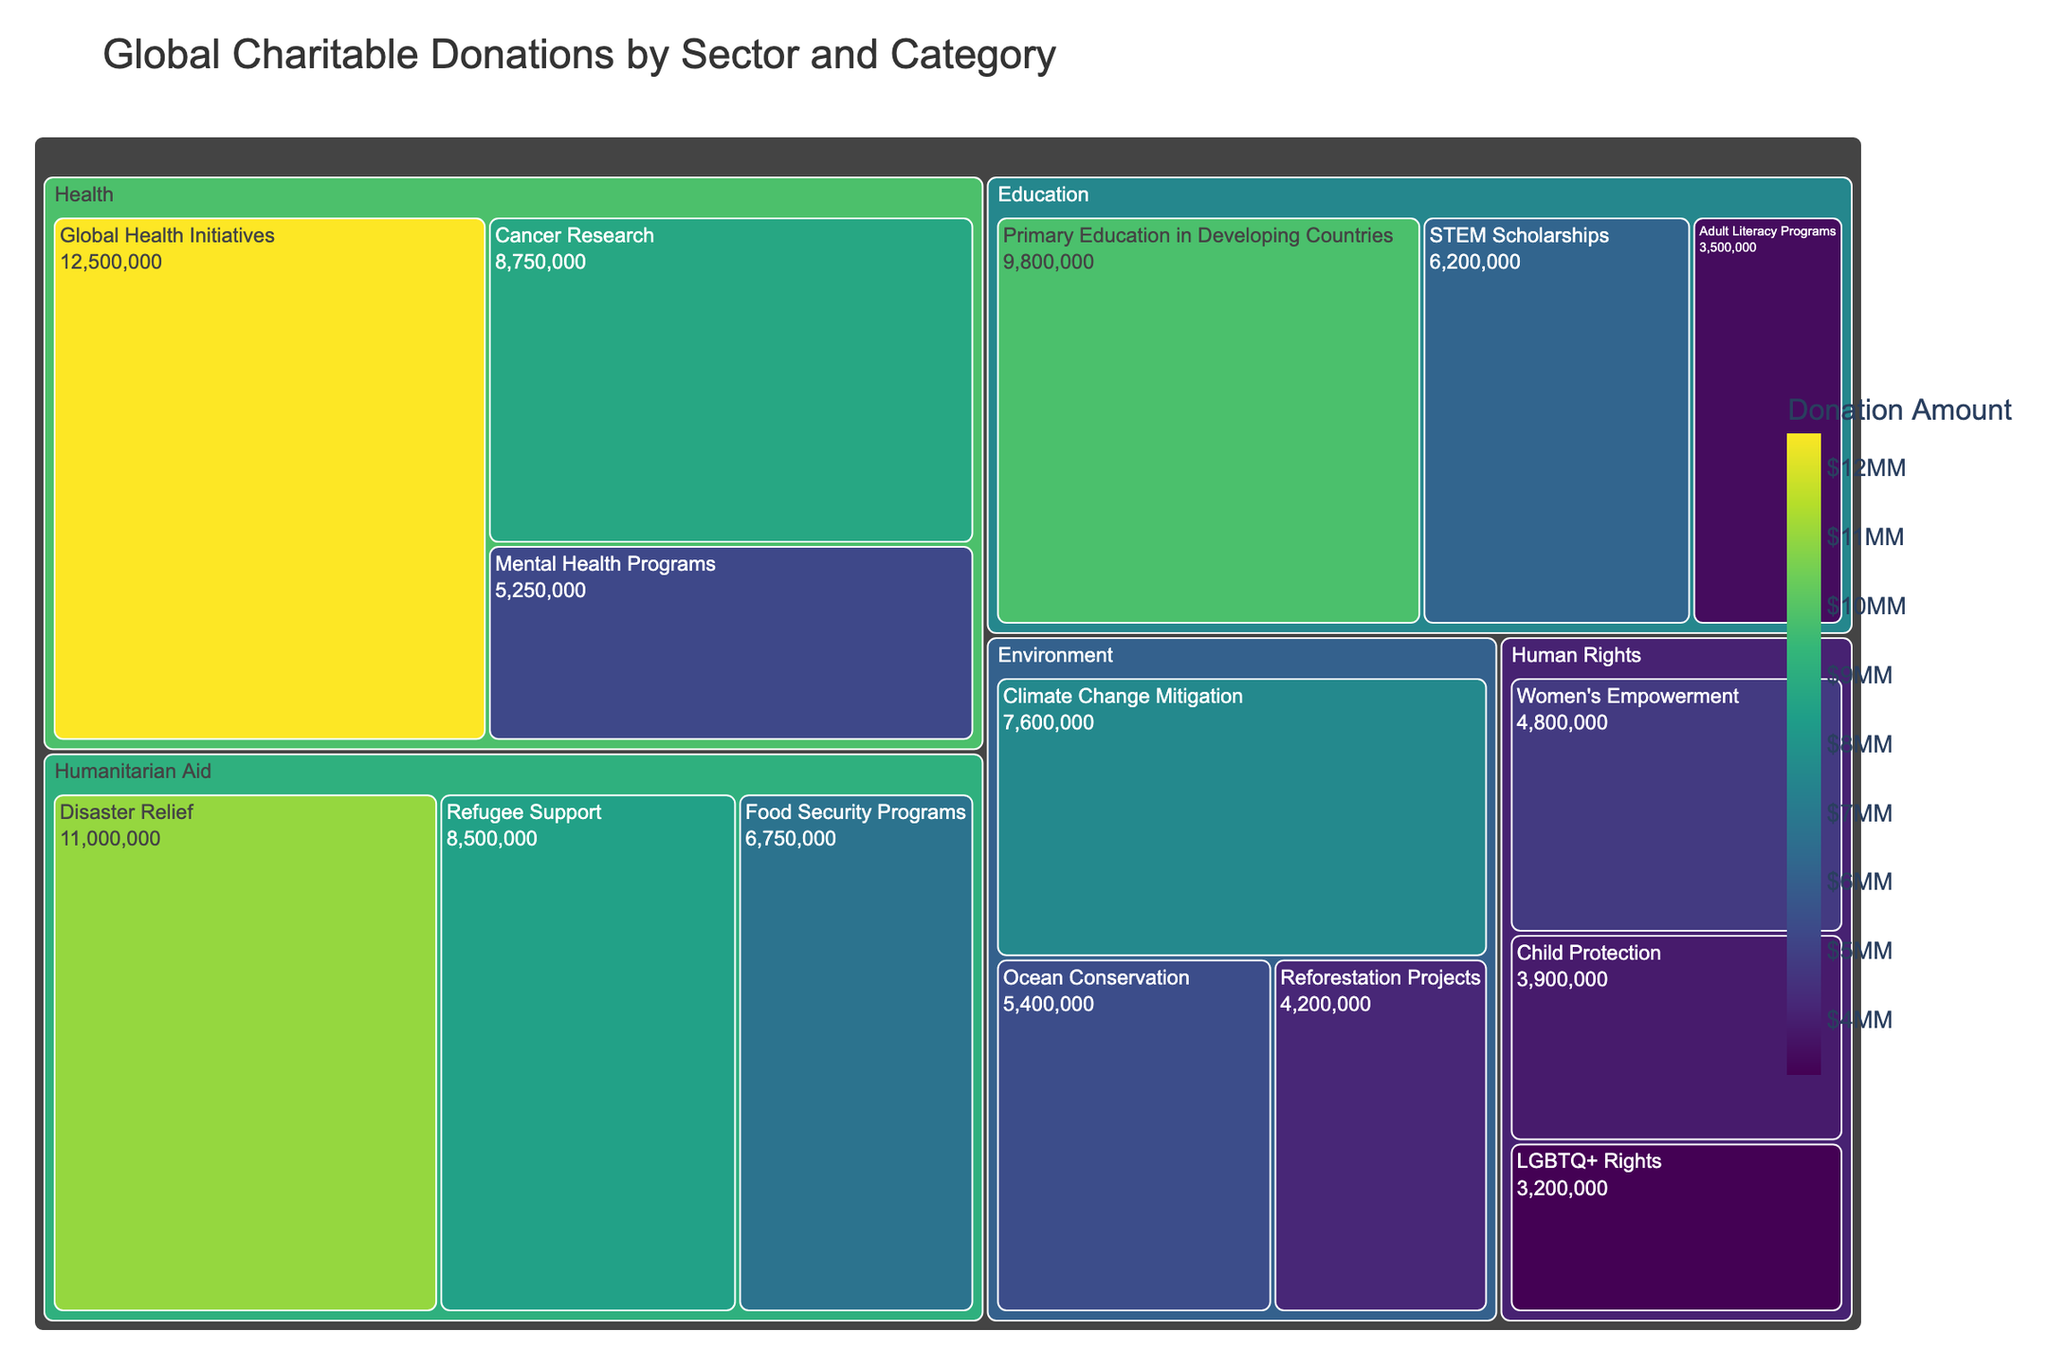What is the title of the figure? The title is usually displayed at the top of the figure. Here, it is labeled clearly.
Answer: Global Charitable Donations by Sector and Category Which sector received the highest donation amount? Check the aggregate amount for each sector by summing the donations for all categories under that sector. The sector with the highest figure is the one with the highest donation.
Answer: Health How much was donated to the Cancer Research category? Look for the specific category under the Health sector and note the amount indicated.
Answer: $8,750,000 What is the smallest donation amount and which category does it belong to? Identify the smallest value in the figure and look for its corresponding category label.
Answer: $3,200,000, LGBTQ+ Rights Compare the donation amounts for Primary Education in Developing Countries and Disaster Relief. Which category received more and by how much? Find the amounts for both categories: Primary Education in Developing Countries ($9,800,000) and Disaster Relief ($11,000,000). Calculate the difference between them.
Answer: Disaster Relief received $1,200,000 more What is the average donation amount across all sectors? Sum all the donation amounts and divide by the number of categories (15). Total amount is $99,000,000. So, $99,000,000 / 15.
Answer: $6,600,000 Which category under the Environmental sector received the highest donation? Compare the donation amounts for Climate Change Mitigation, Ocean Conservation, and Reforestation Projects within the Environmental sector.
Answer: Climate Change Mitigation What percentage of the total donations went to Humanitarian Aid? Calculate the total amount donated to Humanitarian Aid categories, which is $26,000,000. Then divide it by the total donations ($99,000,000) and multiply by 100 to get the percentage. (26,000,000 / 99,000,000) * 100.
Answer: 26.26% Rank the sectors from highest to lowest based on the total donation amounts. Sum up the donation amounts for each sector and arrange them in descending order. Health (26,750,000), Humanitarian Aid (26,000,000), Education (19,500,000), Environment (17,200,000), Human Rights (11,900,000).
Answer: Health > Humanitarian Aid > Education > Environment > Human Rights Which category in the Human Rights sector received the most donations? Look at the Human Rights sector and find the maximum donation among Women's Empowerment, LGBTQ+ Rights, and Child Protection.
Answer: Women's Empowerment 